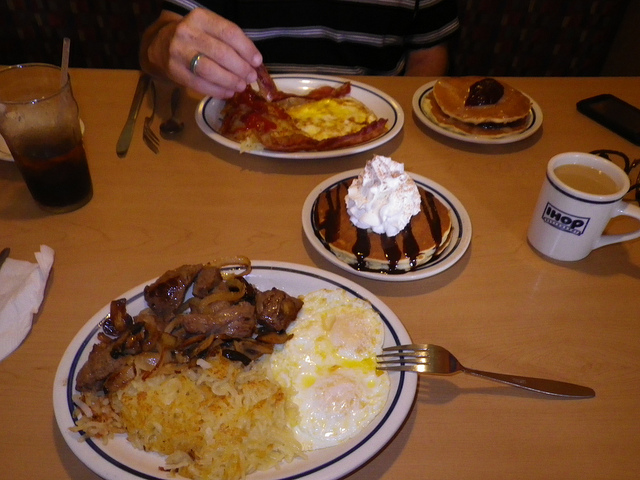Read all the text in this image. HOP IHOP 